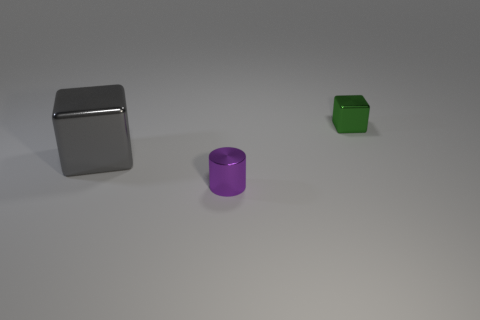Add 3 big red matte things. How many objects exist? 6 Subtract all cylinders. How many objects are left? 2 Add 1 large cyan metal balls. How many large cyan metal balls exist? 1 Subtract 0 purple spheres. How many objects are left? 3 Subtract all tiny yellow spheres. Subtract all purple metallic objects. How many objects are left? 2 Add 3 metal blocks. How many metal blocks are left? 5 